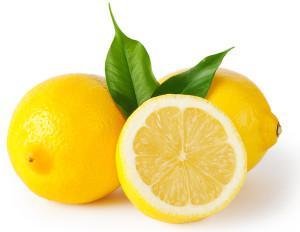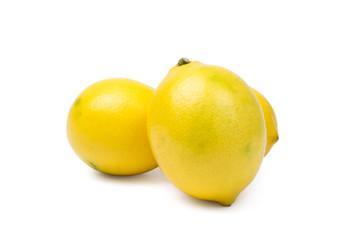The first image is the image on the left, the second image is the image on the right. Considering the images on both sides, is "In at least one image, there are three yellow lemons with at single stock of leaves next to the lemon on the left side." valid? Answer yes or no. No. The first image is the image on the left, the second image is the image on the right. Assess this claim about the two images: "Exactly one of the images of lemons includes leaves.". Correct or not? Answer yes or no. Yes. 